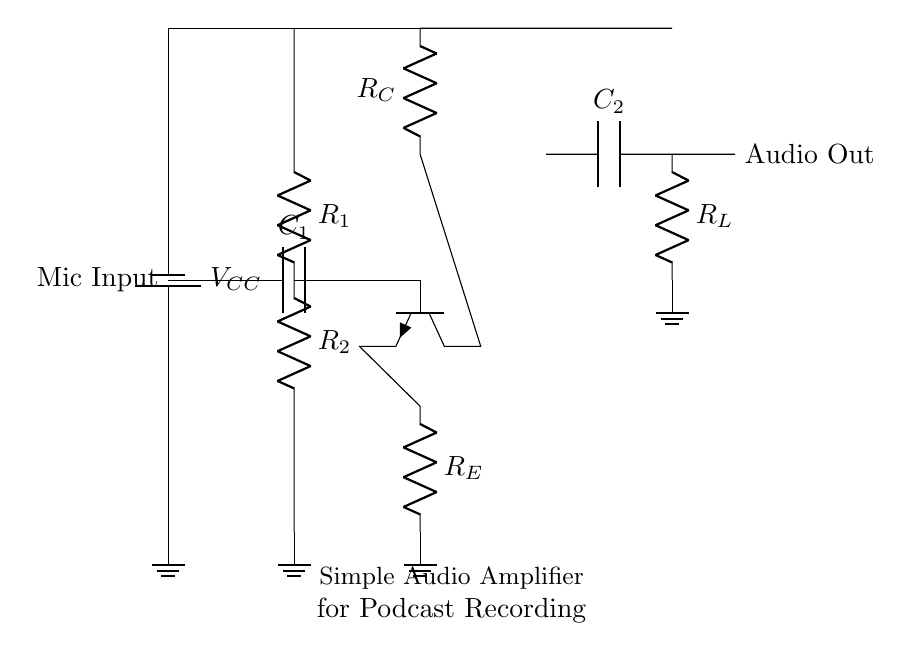What type of transistor is used in the circuit? The circuit uses an NPN transistor, as indicated by the symbol for the transistor shown in the diagram.
Answer: NPN What is the purpose of capacitor C1? Capacitor C1 is typically used for coupling, allowing AC signals (audio) to pass through while blocking DC components from the microphone.
Answer: Coupling How many resistors are present in the circuit? There are three resistors in the circuit: R1, R2, and RE, as can be counted directly from the diagram.
Answer: Three What is the role of the power supply in this circuit? The power supply provides the necessary voltage (VCC) for the transistor to amplify the input signal, acting as the energy source for the circuit operation.
Answer: Amplification What type of circuit is this? This circuit is an analog audio amplifier designed to increase the amplitude of audio signals for better recording quality.
Answer: Analog audio amplifier Which component is responsible for the output connection? The output connection is made through the load resistor R_L that connects to the audio output node, facilitating the transfer of the amplified signal.
Answer: R_L 